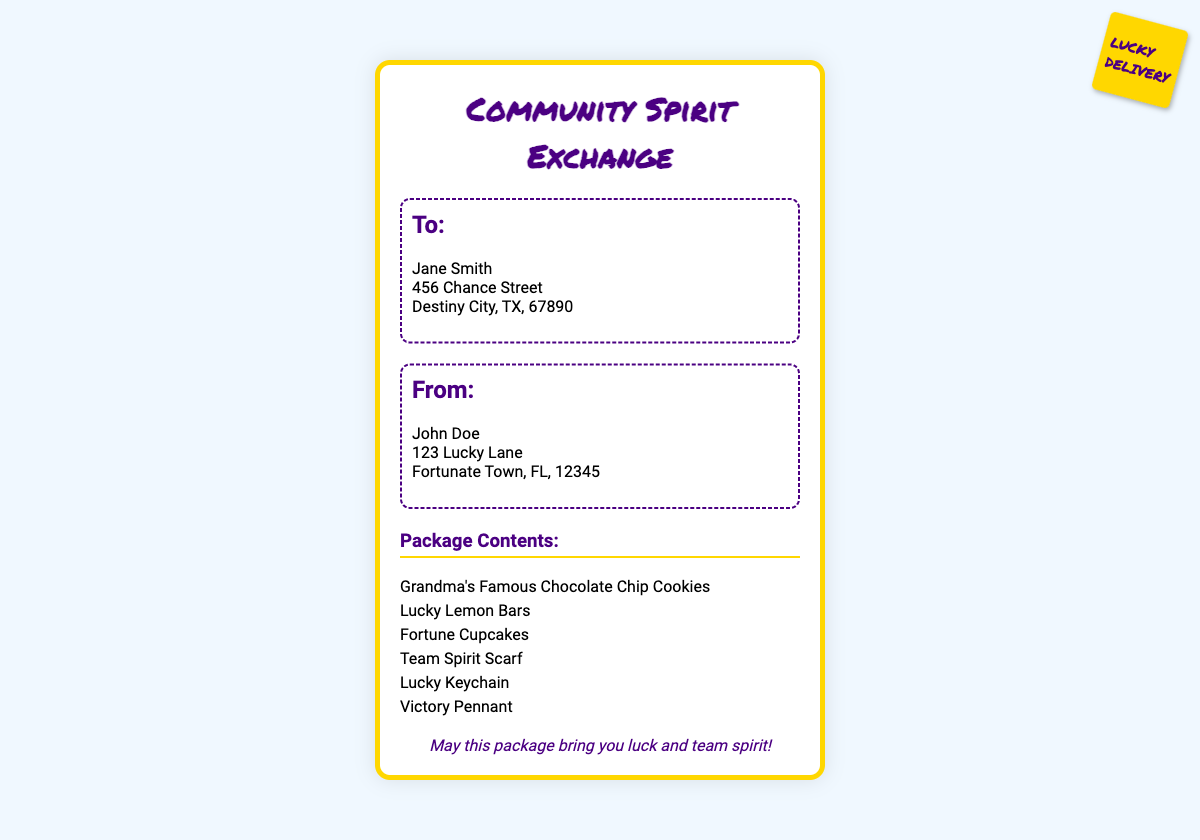What is the name of the sender? The sender's name is listed in the 'From' section of the document as John Doe.
Answer: John Doe What is the address of the recipient? The recipient's address is found in the 'To' section, detailing street address and city.
Answer: 456 Chance Street, Destiny City, TX, 67890 How many items are listed in the package contents? The total number of items is found by counting the entries under 'Package Contents'.
Answer: 6 What is the first item mentioned in the package contents? The first item is the top entry in the 'Package Contents' list.
Answer: Grandma's Famous Chocolate Chip Cookies What message is included in the document? The document contains a specific lucky message for the recipient within the lucky-message section.
Answer: May this package bring you luck and team spirit! What type of document is this? This document is categorized as a shipping label, as identified by the title and formatting.
Answer: Shipping label 